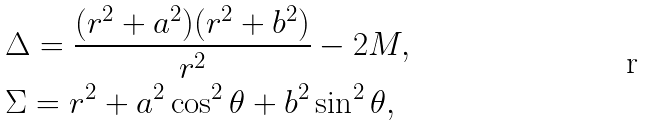Convert formula to latex. <formula><loc_0><loc_0><loc_500><loc_500>& \Delta = \frac { ( r ^ { 2 } + a ^ { 2 } ) ( r ^ { 2 } + b ^ { 2 } ) } { r ^ { 2 } } - 2 M , \\ & \Sigma = r ^ { 2 } + a ^ { 2 } \cos ^ { 2 } \theta + b ^ { 2 } \sin ^ { 2 } \theta ,</formula> 